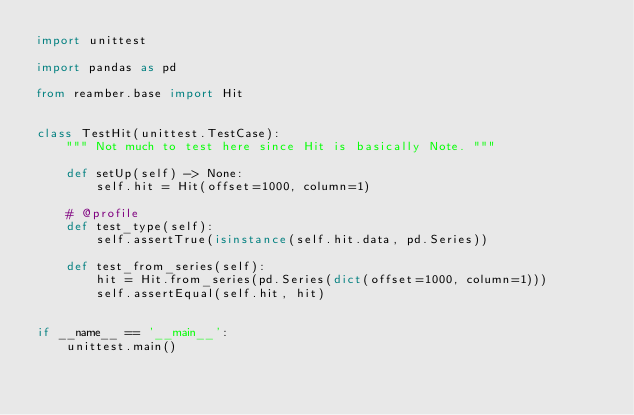Convert code to text. <code><loc_0><loc_0><loc_500><loc_500><_Python_>import unittest

import pandas as pd

from reamber.base import Hit


class TestHit(unittest.TestCase):
    """ Not much to test here since Hit is basically Note. """

    def setUp(self) -> None:
        self.hit = Hit(offset=1000, column=1)

    # @profile
    def test_type(self):
        self.assertTrue(isinstance(self.hit.data, pd.Series))

    def test_from_series(self):
        hit = Hit.from_series(pd.Series(dict(offset=1000, column=1)))
        self.assertEqual(self.hit, hit)


if __name__ == '__main__':
    unittest.main()
</code> 